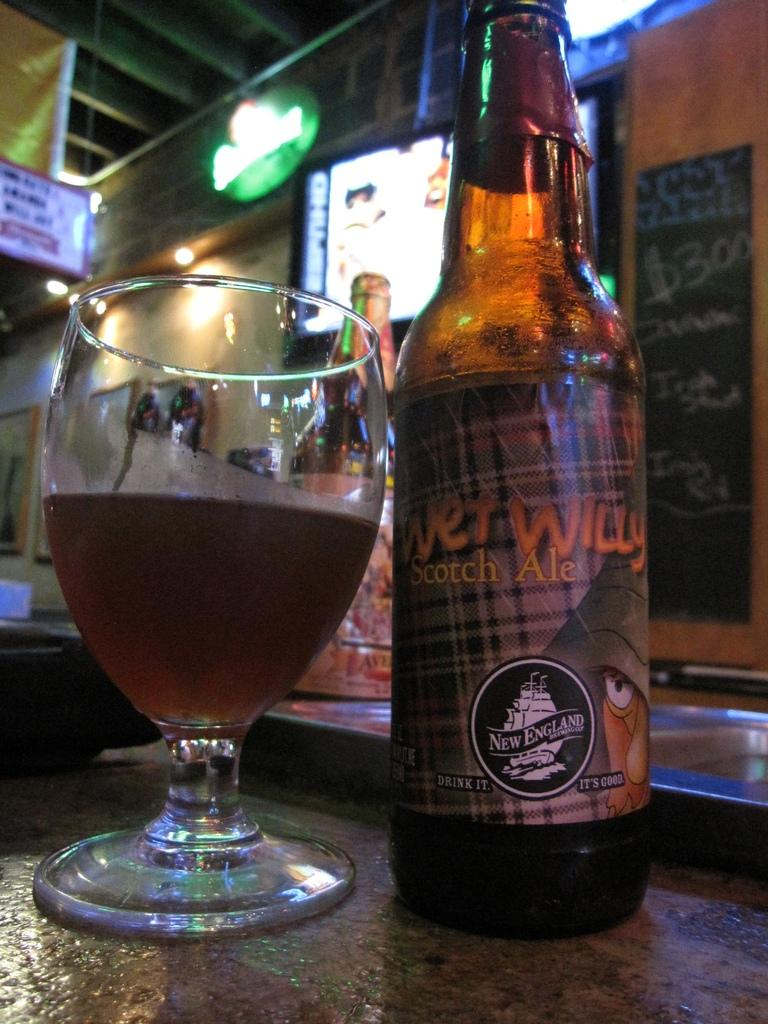What is in the glass that is visible in the image? There is a drink in the glass in the image. What other beverage container is present in the image? There is a bottle in the image. Where are the glass and the bottle located in the image? Both the glass and the bottle are on the floor in the image. What can be seen in the background of the image? There is another bottle, a screen, and a light visible in the background of the image. Can you describe the stream that is flowing through the mouth of the bottle in the image? There is no stream flowing through the mouth of the bottle in the image; it is a solid object with no liquid flowing from it. 